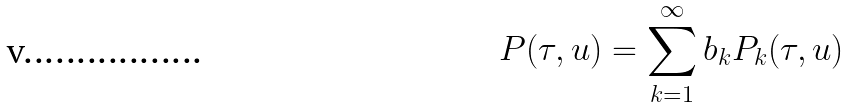<formula> <loc_0><loc_0><loc_500><loc_500>P ( \tau , u ) = \sum _ { k = 1 } ^ { \infty } b _ { k } P _ { k } ( \tau , u )</formula> 